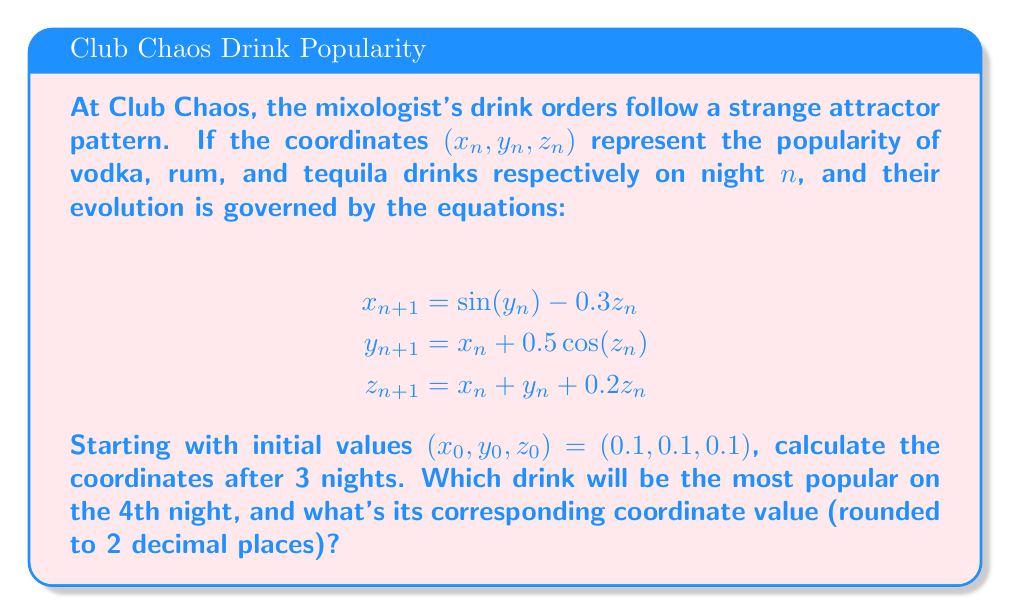Can you solve this math problem? Let's calculate the coordinates for each night:

Night 1 $(n=0)$:
$x_0 = 0.1$, $y_0 = 0.1$, $z_0 = 0.1$

Night 2 $(n=1)$:
$$x_1 = \sin(0.1) - 0.3(0.1) = 0.0998 - 0.03 = 0.0698$$
$$y_1 = 0.1 + 0.5\cos(0.1) = 0.1 + 0.4988 = 0.5988$$
$$z_1 = 0.1 + 0.1 + 0.2(0.1) = 0.22$$

Night 3 $(n=2)$:
$$x_2 = \sin(0.5988) - 0.3(0.22) = 0.5652 - 0.066 = 0.4992$$
$$y_2 = 0.0698 + 0.5\cos(0.22) = 0.0698 + 0.4879 = 0.5577$$
$$z_2 = 0.0698 + 0.5988 + 0.2(0.22) = 0.7130$$

Night 4 $(n=3)$:
$$x_3 = \sin(0.5577) - 0.3(0.7130) = 0.5284 - 0.2139 = 0.3145$$
$$y_3 = 0.4992 + 0.5\cos(0.7130) = 0.4992 + 0.3876 = 0.8868$$
$$z_3 = 0.4992 + 0.5577 + 0.2(0.7130) = 1.1995$$

On the 4th night $(n=3)$, the largest coordinate value is $z_3 = 1.1995$, corresponding to tequila drinks.
Answer: Tequila, 1.20 